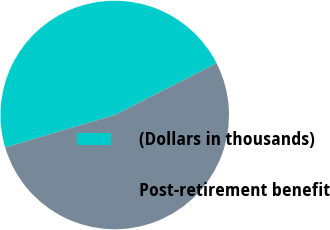Convert chart. <chart><loc_0><loc_0><loc_500><loc_500><pie_chart><fcel>(Dollars in thousands)<fcel>Post-retirement benefit<nl><fcel>47.11%<fcel>52.89%<nl></chart> 